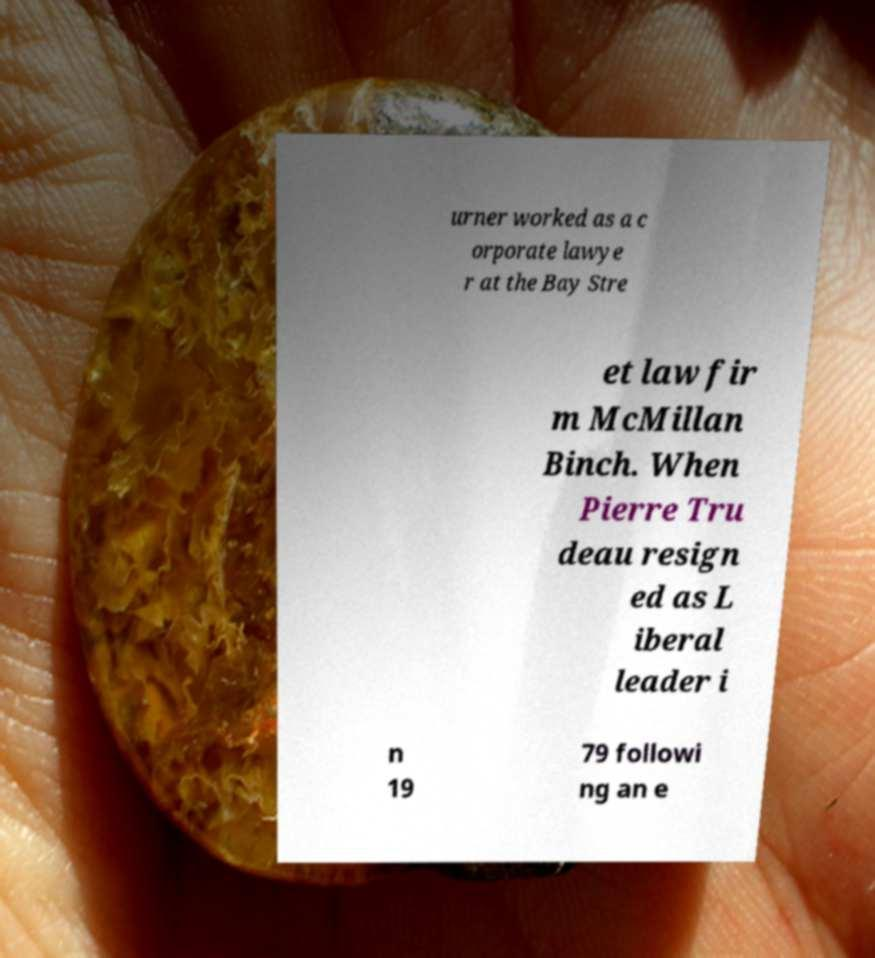Can you accurately transcribe the text from the provided image for me? urner worked as a c orporate lawye r at the Bay Stre et law fir m McMillan Binch. When Pierre Tru deau resign ed as L iberal leader i n 19 79 followi ng an e 